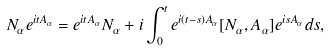<formula> <loc_0><loc_0><loc_500><loc_500>N _ { \alpha } e ^ { i t A _ { \alpha } } = e ^ { i t A _ { \alpha } } N _ { \alpha } + i \int _ { 0 } ^ { t } e ^ { i ( t - s ) A _ { \alpha } } [ N _ { \alpha } , A _ { \alpha } ] e ^ { i s A _ { \alpha } } d s ,</formula> 